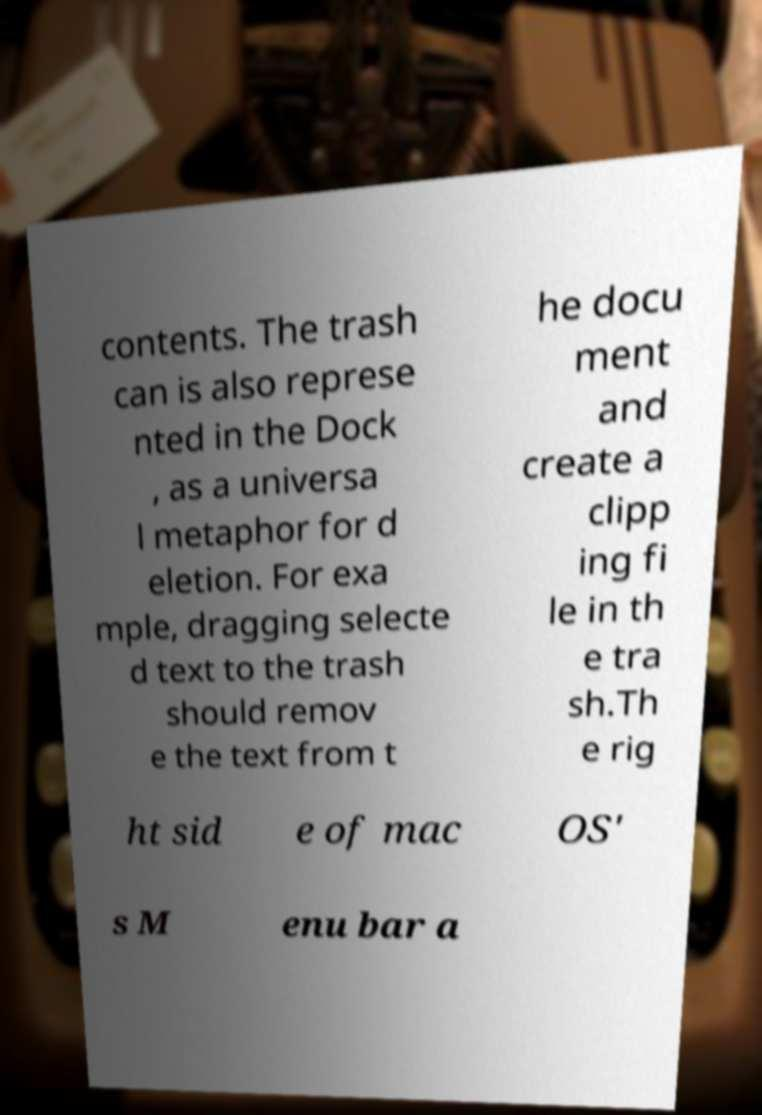Please read and relay the text visible in this image. What does it say? contents. The trash can is also represe nted in the Dock , as a universa l metaphor for d eletion. For exa mple, dragging selecte d text to the trash should remov e the text from t he docu ment and create a clipp ing fi le in th e tra sh.Th e rig ht sid e of mac OS' s M enu bar a 